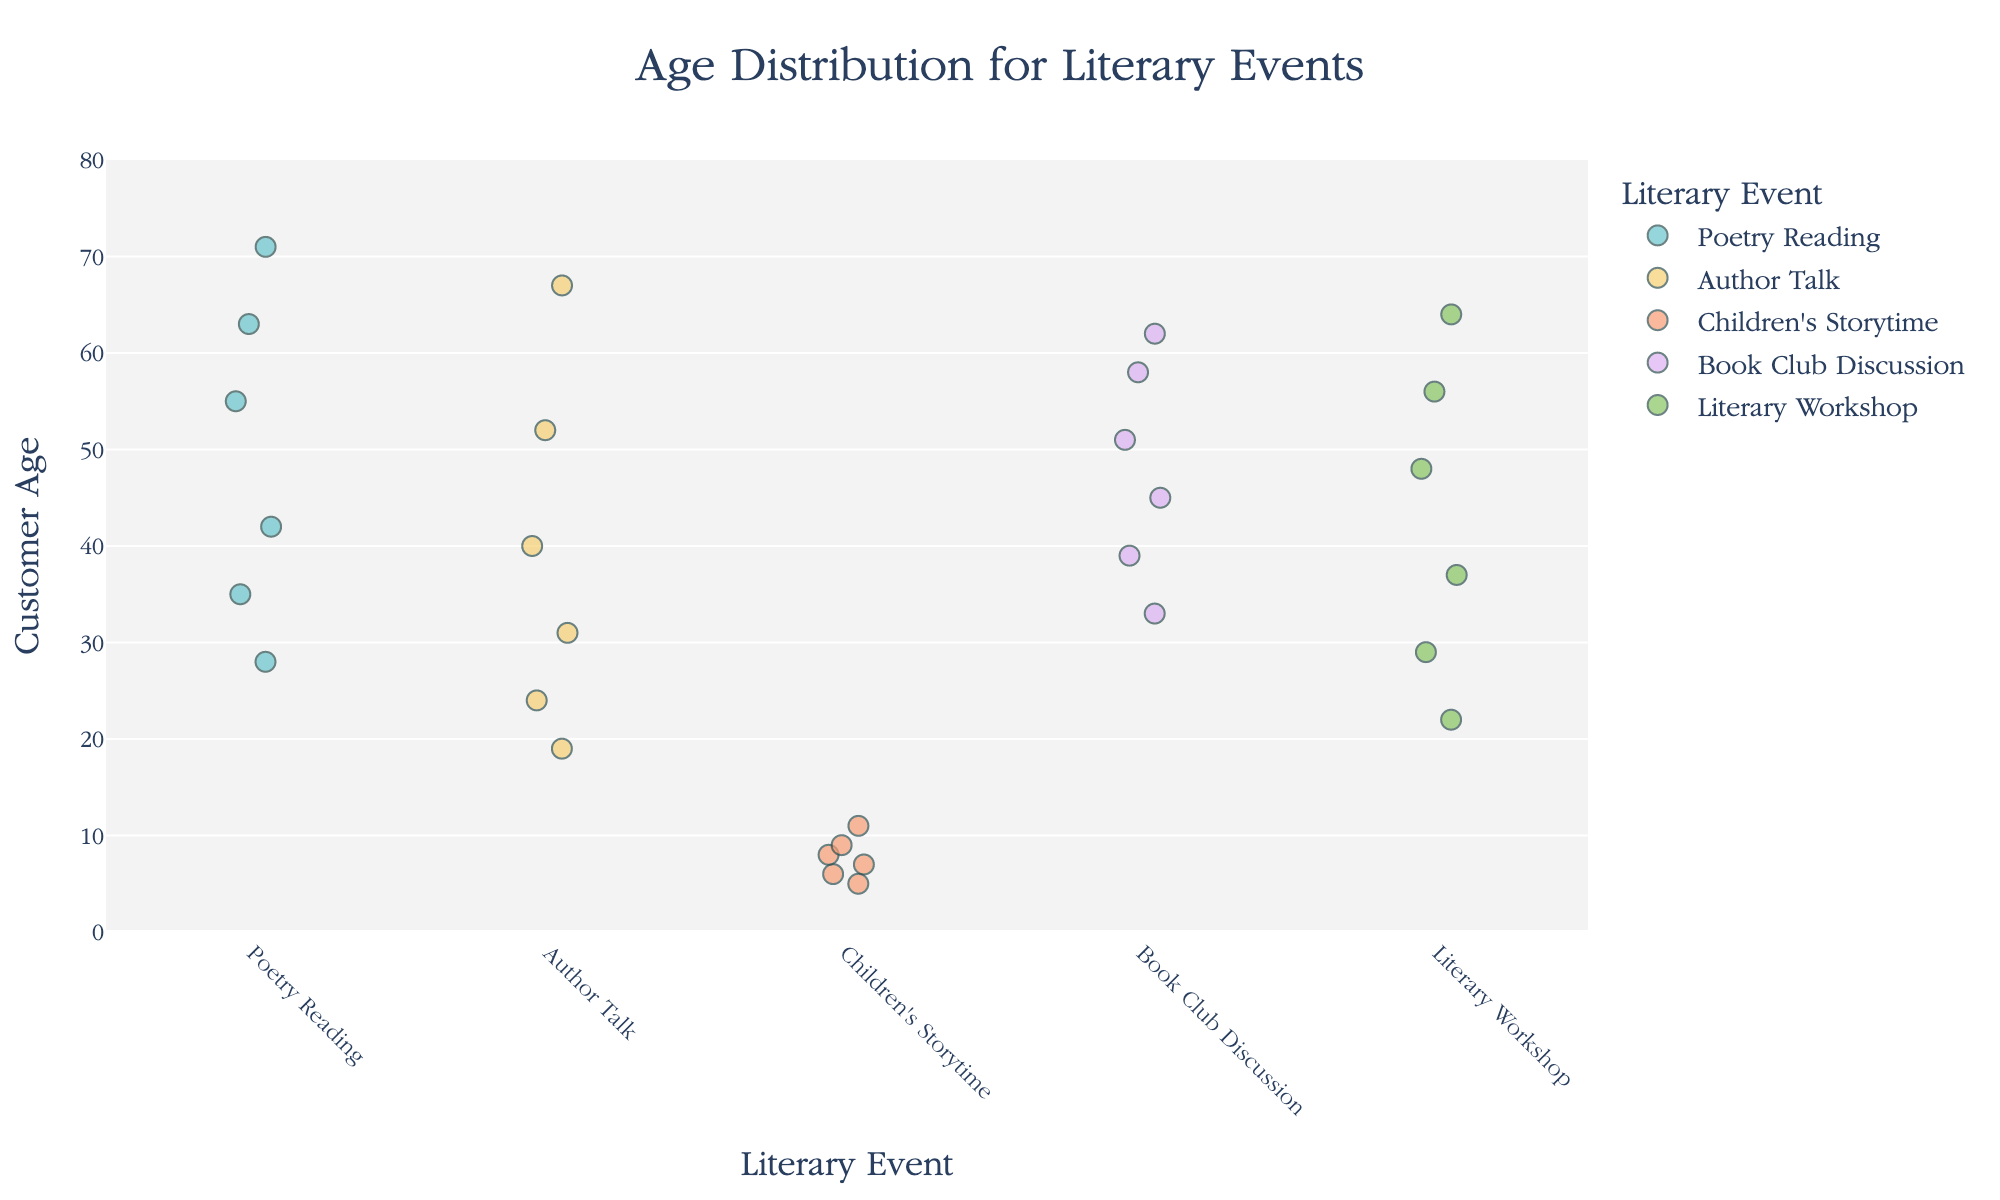Which event has the youngest average age? Calculate the average age for each event: Poetry Reading has (28+35+42+55+63+71)/6 ≈ 49, Author Talk has (19+24+31+40+52+67)/6 ≈ 39, Children's Storytime has (5+7+9+11+6+8)/6 ≈ 7.67, Book Club Discussion has (33+45+58+62+39+51)/6 ≈ 48, Literary Workshop has (22+29+37+48+56+64)/6 ≈ 42.67. Thus, Children's Storytime has the youngest average age.
Answer: Children's Storytime How many data points are there for the Author Talk event? Count the number of data points for Author Talk in the figure. There are 6 ages listed: 19, 24, 31, 40, 52, 67.
Answer: 6 Which event attracts the widest range of ages? Calculate the age range (max - min) for each event: Poetry Reading (71-28=43), Author Talk (67-19=48), Children's Storytime (11-5=6), Book Club Discussion (62-33=29), Literary Workshop (64-22=42). Author Talk has the widest age range.
Answer: Author Talk Which event has the most data points? Count the number of data points for each event: Poetry Reading has 6, Author Talk has 6, Children's Storytime has 6, Book Club Discussion has 6, Literary Workshop has 6. All events have the same number of data points.
Answer: All events have the same count What is the median age for Book Club Discussion attendees? List the ages for Book Club Discussion: 33, 45, 58, 62, 39, 51. Sort them: 33, 39, 45, 51, 58, 62. The median is the average of the two middle numbers (45+51)/2 = 48.
Answer: 48 Which event has the oldest participant? Identify the maximum ages for each event: Poetry Reading (71), Author Talk (67), Children's Storytime (11), Book Club Discussion (62), Literary Workshop (64). The oldest participant is at Poetry Reading (71).
Answer: Poetry Reading How does the average age of Poetry Reading compare to Book Club Discussion? Calculate the average ages for both events: Poetry Reading (49), Book Club Discussion (48). Poetry Reading's average age is slightly higher.
Answer: Higher What is the age range for Children's Storytime? Identify the minimum and maximum ages: minimum is 5 and maximum is 11. The range is 11 - 5 = 6.
Answer: 6 Among the listed events, which two have the closest average ages? Calculate the averages and compare: Poetry Reading (49), Author Talk (39), Children's Storytime (7.67), Book Club Discussion (48), Literary Workshop (42.67). Book Club Discussion (48) is closest to Poetry Reading (49).
Answer: Poetry Reading and Book Club Discussion What is the difference in the median ages for Children's Storytime and Literary Workshop? Median for Children's Storytime (6.5): (5, 6, 7, 8, 9, 11), median for Literary Workshop (42.5): (22, 29, 37, 48, 56, 64). The difference is 42.5 - 6.5 = 36.
Answer: 36 